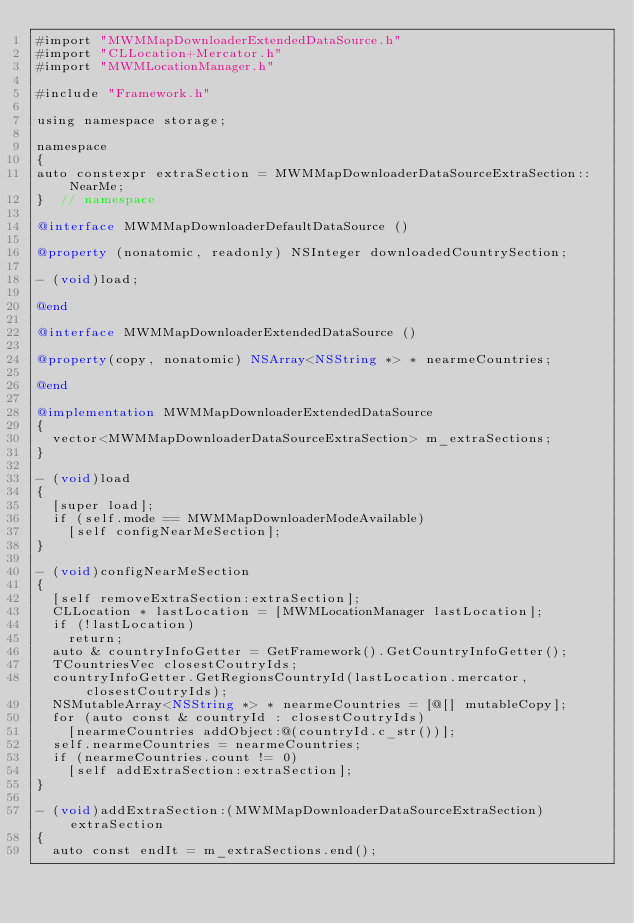<code> <loc_0><loc_0><loc_500><loc_500><_ObjectiveC_>#import "MWMMapDownloaderExtendedDataSource.h"
#import "CLLocation+Mercator.h"
#import "MWMLocationManager.h"

#include "Framework.h"

using namespace storage;

namespace
{
auto constexpr extraSection = MWMMapDownloaderDataSourceExtraSection::NearMe;
}  // namespace

@interface MWMMapDownloaderDefaultDataSource ()

@property (nonatomic, readonly) NSInteger downloadedCountrySection;

- (void)load;

@end

@interface MWMMapDownloaderExtendedDataSource ()

@property(copy, nonatomic) NSArray<NSString *> * nearmeCountries;

@end

@implementation MWMMapDownloaderExtendedDataSource
{
  vector<MWMMapDownloaderDataSourceExtraSection> m_extraSections;
}

- (void)load
{
  [super load];
  if (self.mode == MWMMapDownloaderModeAvailable)
    [self configNearMeSection];
}

- (void)configNearMeSection
{
  [self removeExtraSection:extraSection];
  CLLocation * lastLocation = [MWMLocationManager lastLocation];
  if (!lastLocation)
    return;
  auto & countryInfoGetter = GetFramework().GetCountryInfoGetter();
  TCountriesVec closestCoutryIds;
  countryInfoGetter.GetRegionsCountryId(lastLocation.mercator, closestCoutryIds);
  NSMutableArray<NSString *> * nearmeCountries = [@[] mutableCopy];
  for (auto const & countryId : closestCoutryIds)
    [nearmeCountries addObject:@(countryId.c_str())];
  self.nearmeCountries = nearmeCountries;
  if (nearmeCountries.count != 0)
    [self addExtraSection:extraSection];
}

- (void)addExtraSection:(MWMMapDownloaderDataSourceExtraSection)extraSection
{
  auto const endIt = m_extraSections.end();</code> 